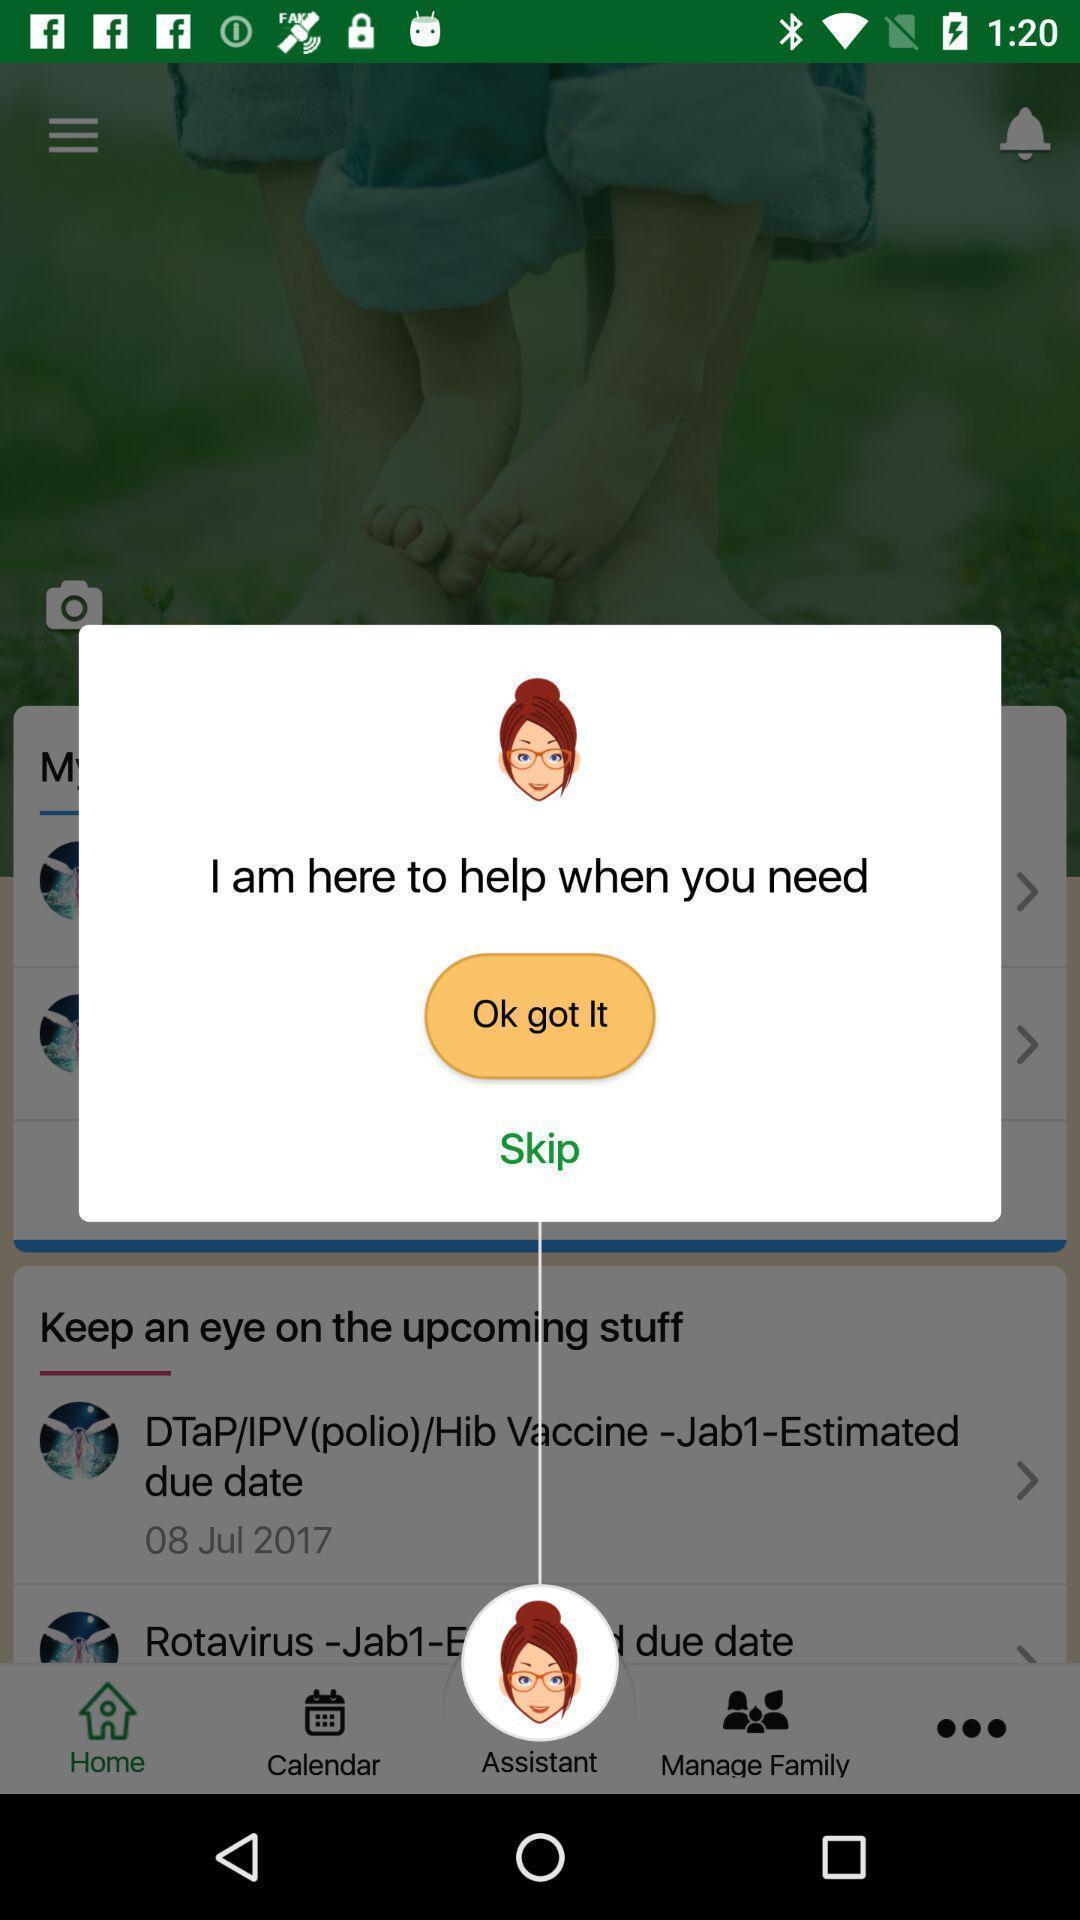What can you discern from this picture? Pop-up shows assistance note in a health app. 